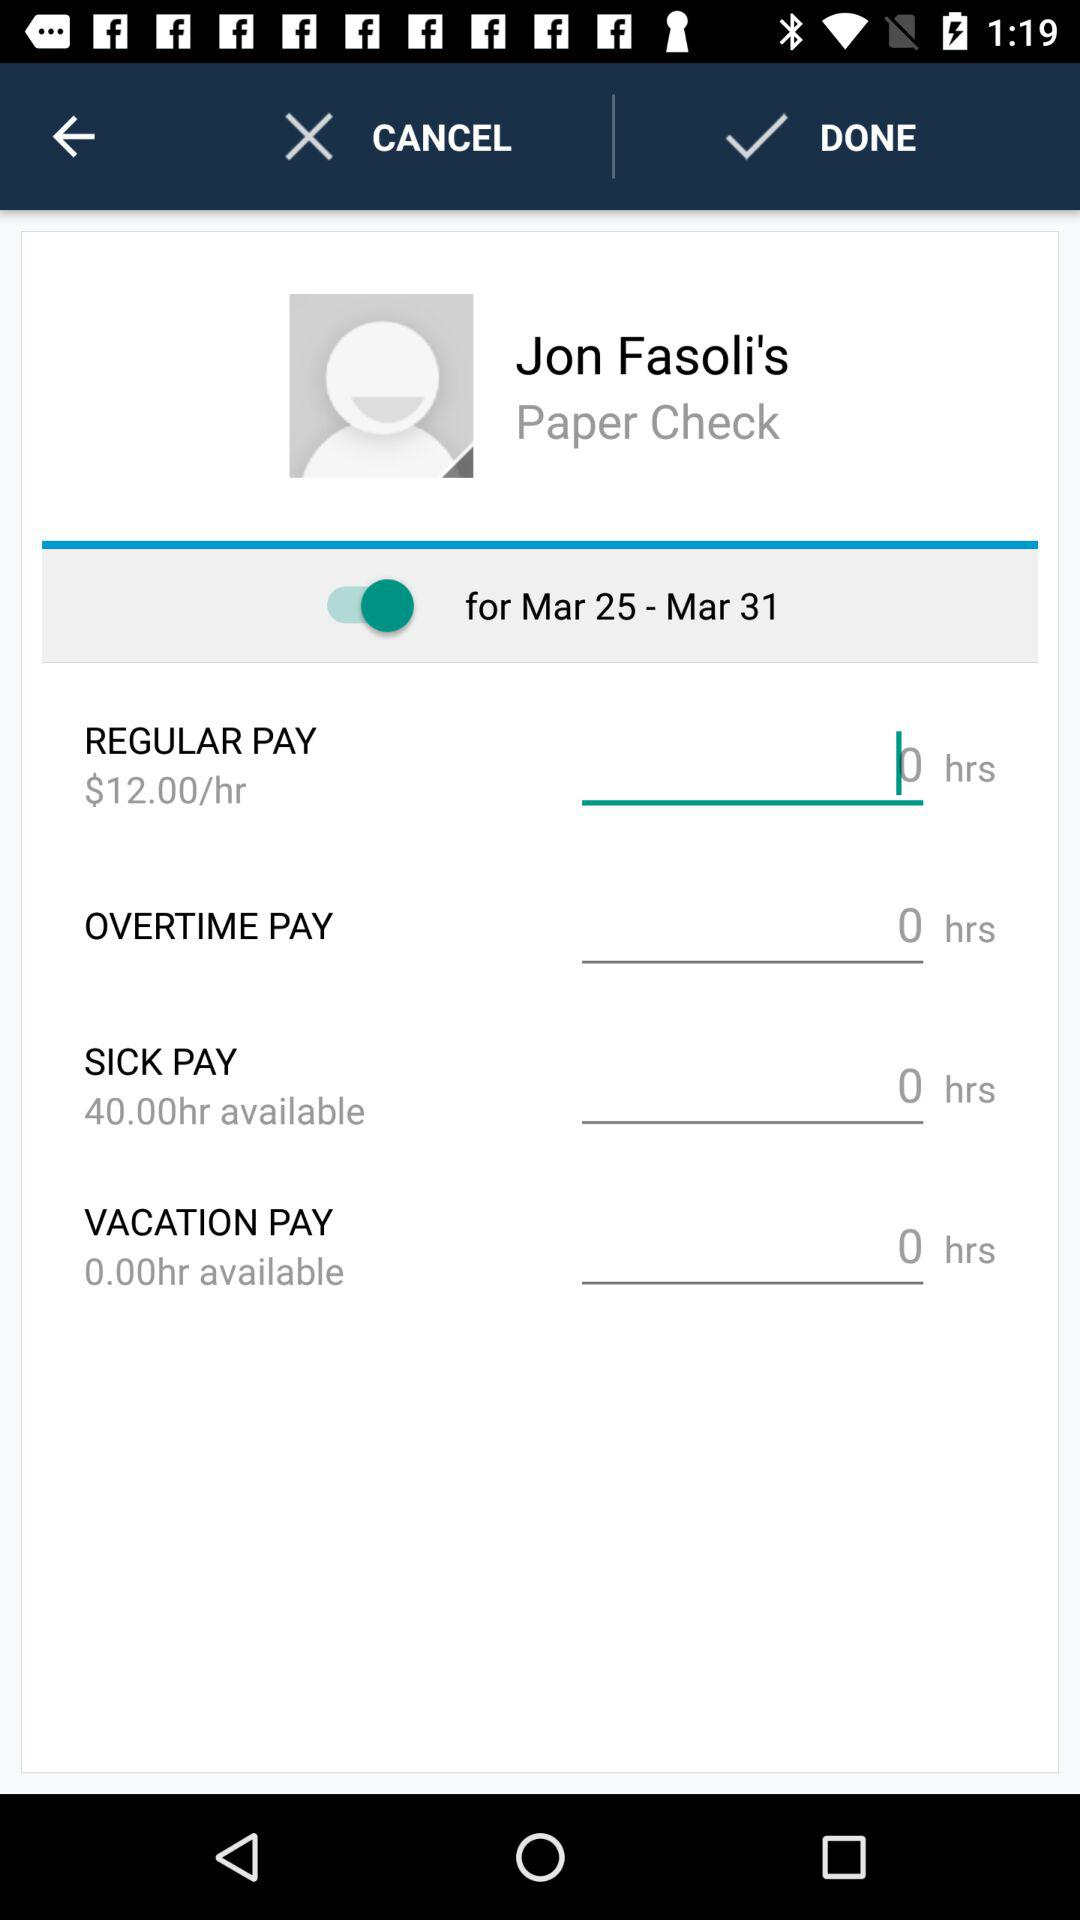How many hours of overtime pay does Jon Fasoli have?
Answer the question using a single word or phrase. 0 